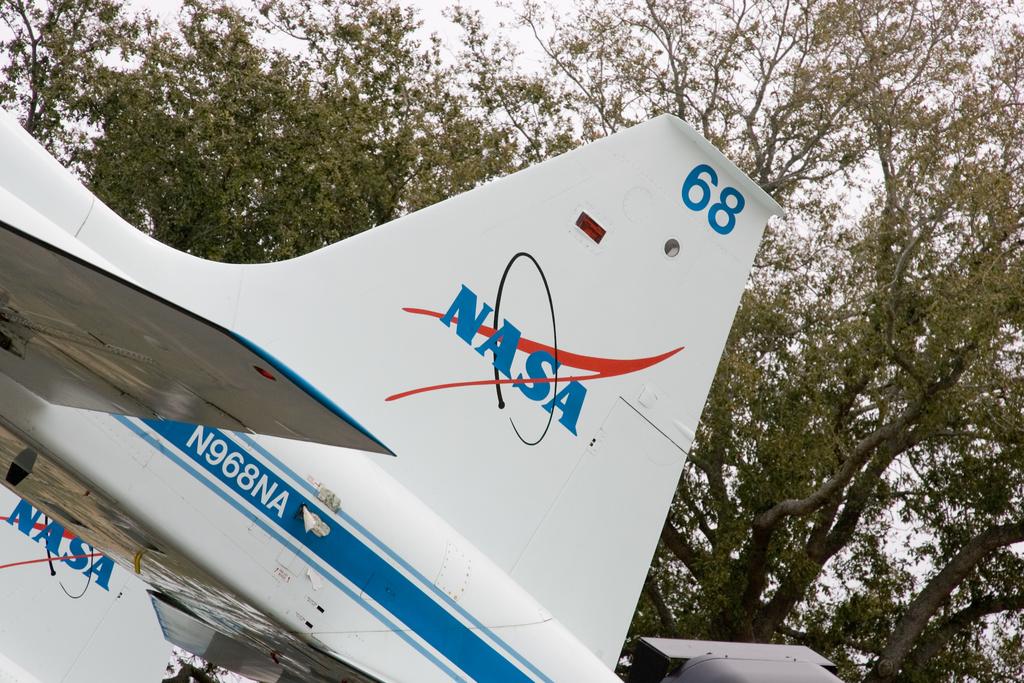What is the number on the tail?
Provide a short and direct response. 68. 